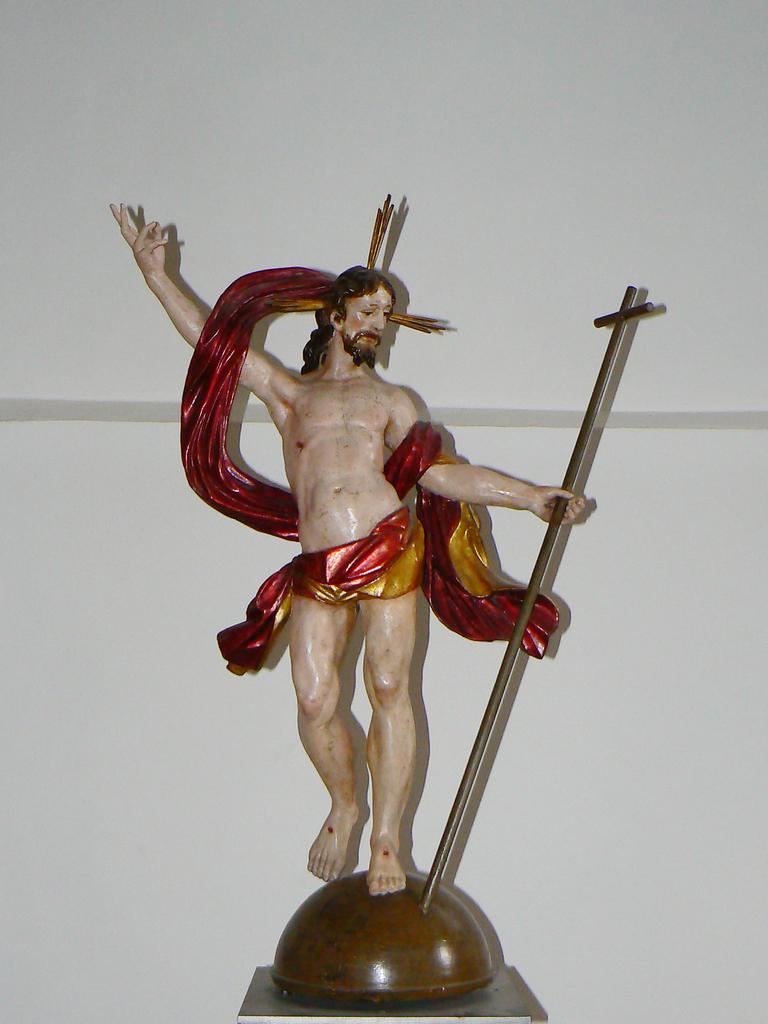Please provide a concise description of this image. In the center of the image we can see a sculpture. In the background there is a wall. 